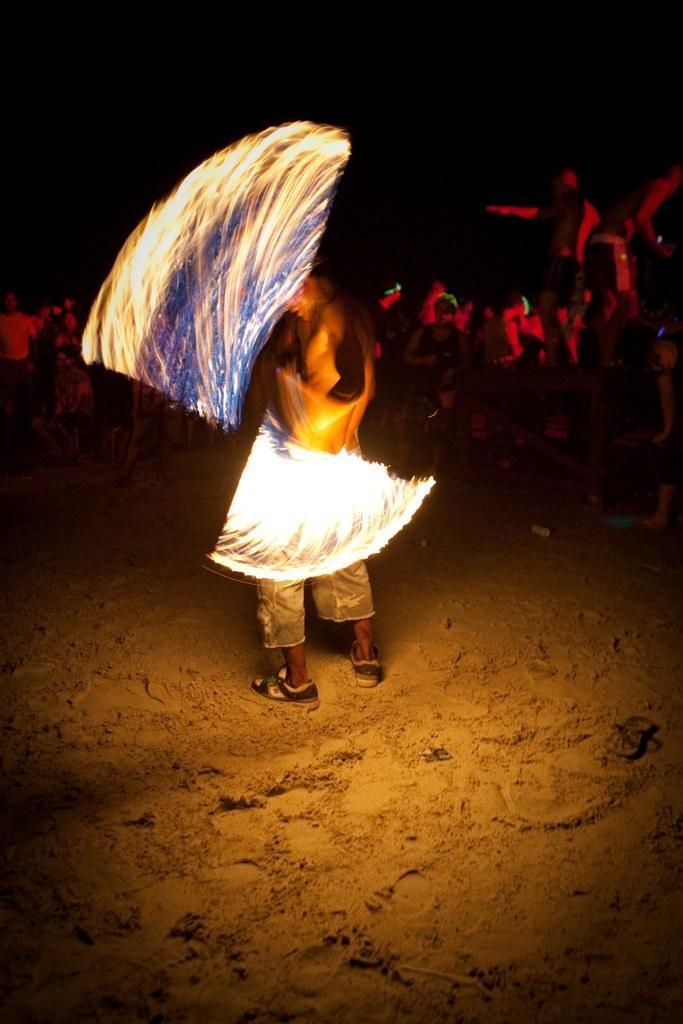Describe this image in one or two sentences. In this image, we can see the fire and person on the sand. In the background, we can see a group of people and dark view. 